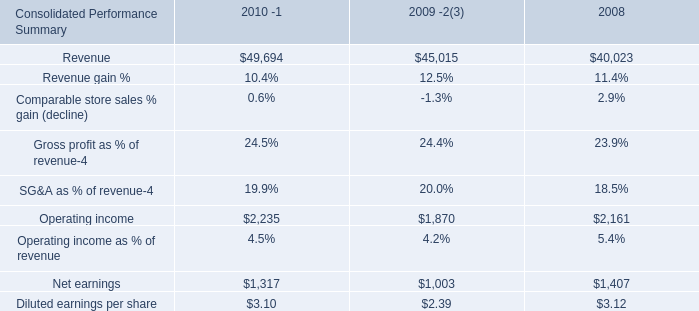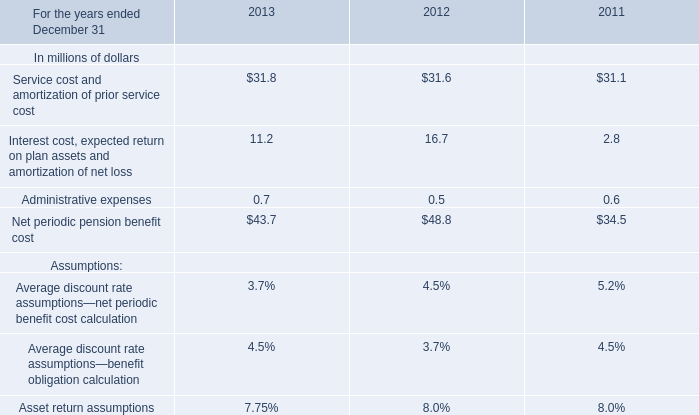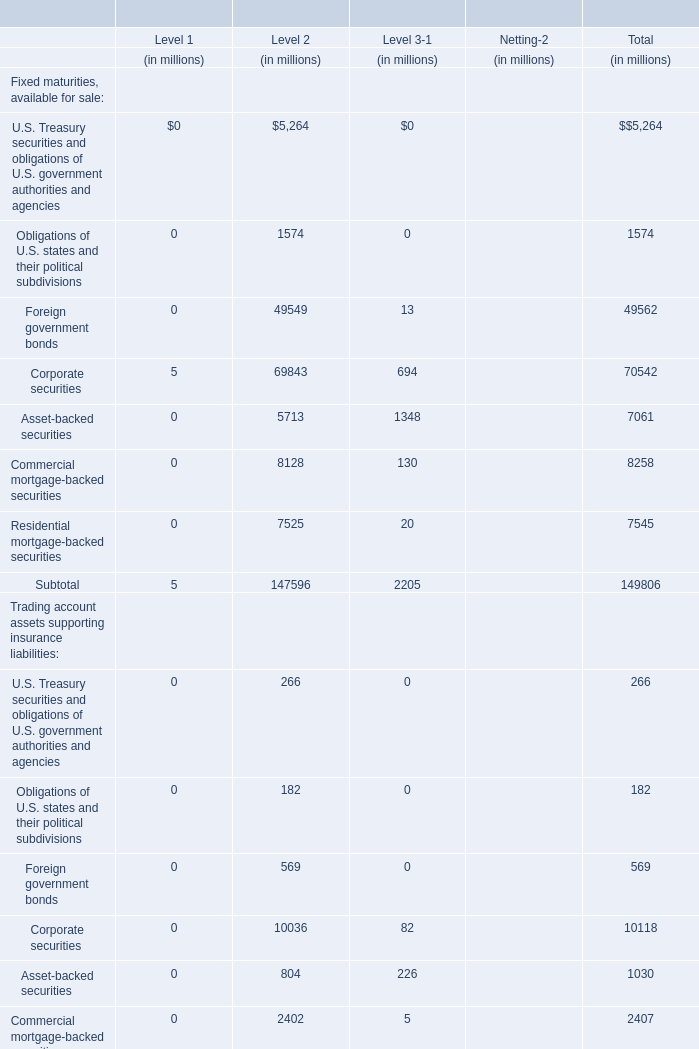What is the sum of Asset return assumptions in 2011 and Operating income as % of revenue in 2008? (in %) 
Computations: (8 + 5.4)
Answer: 13.4. What's the 10 % of total elements of Fixed maturities, available for sale in for Total in 2010? (in million) 
Computations: (149806 * 0.1)
Answer: 14980.6. 